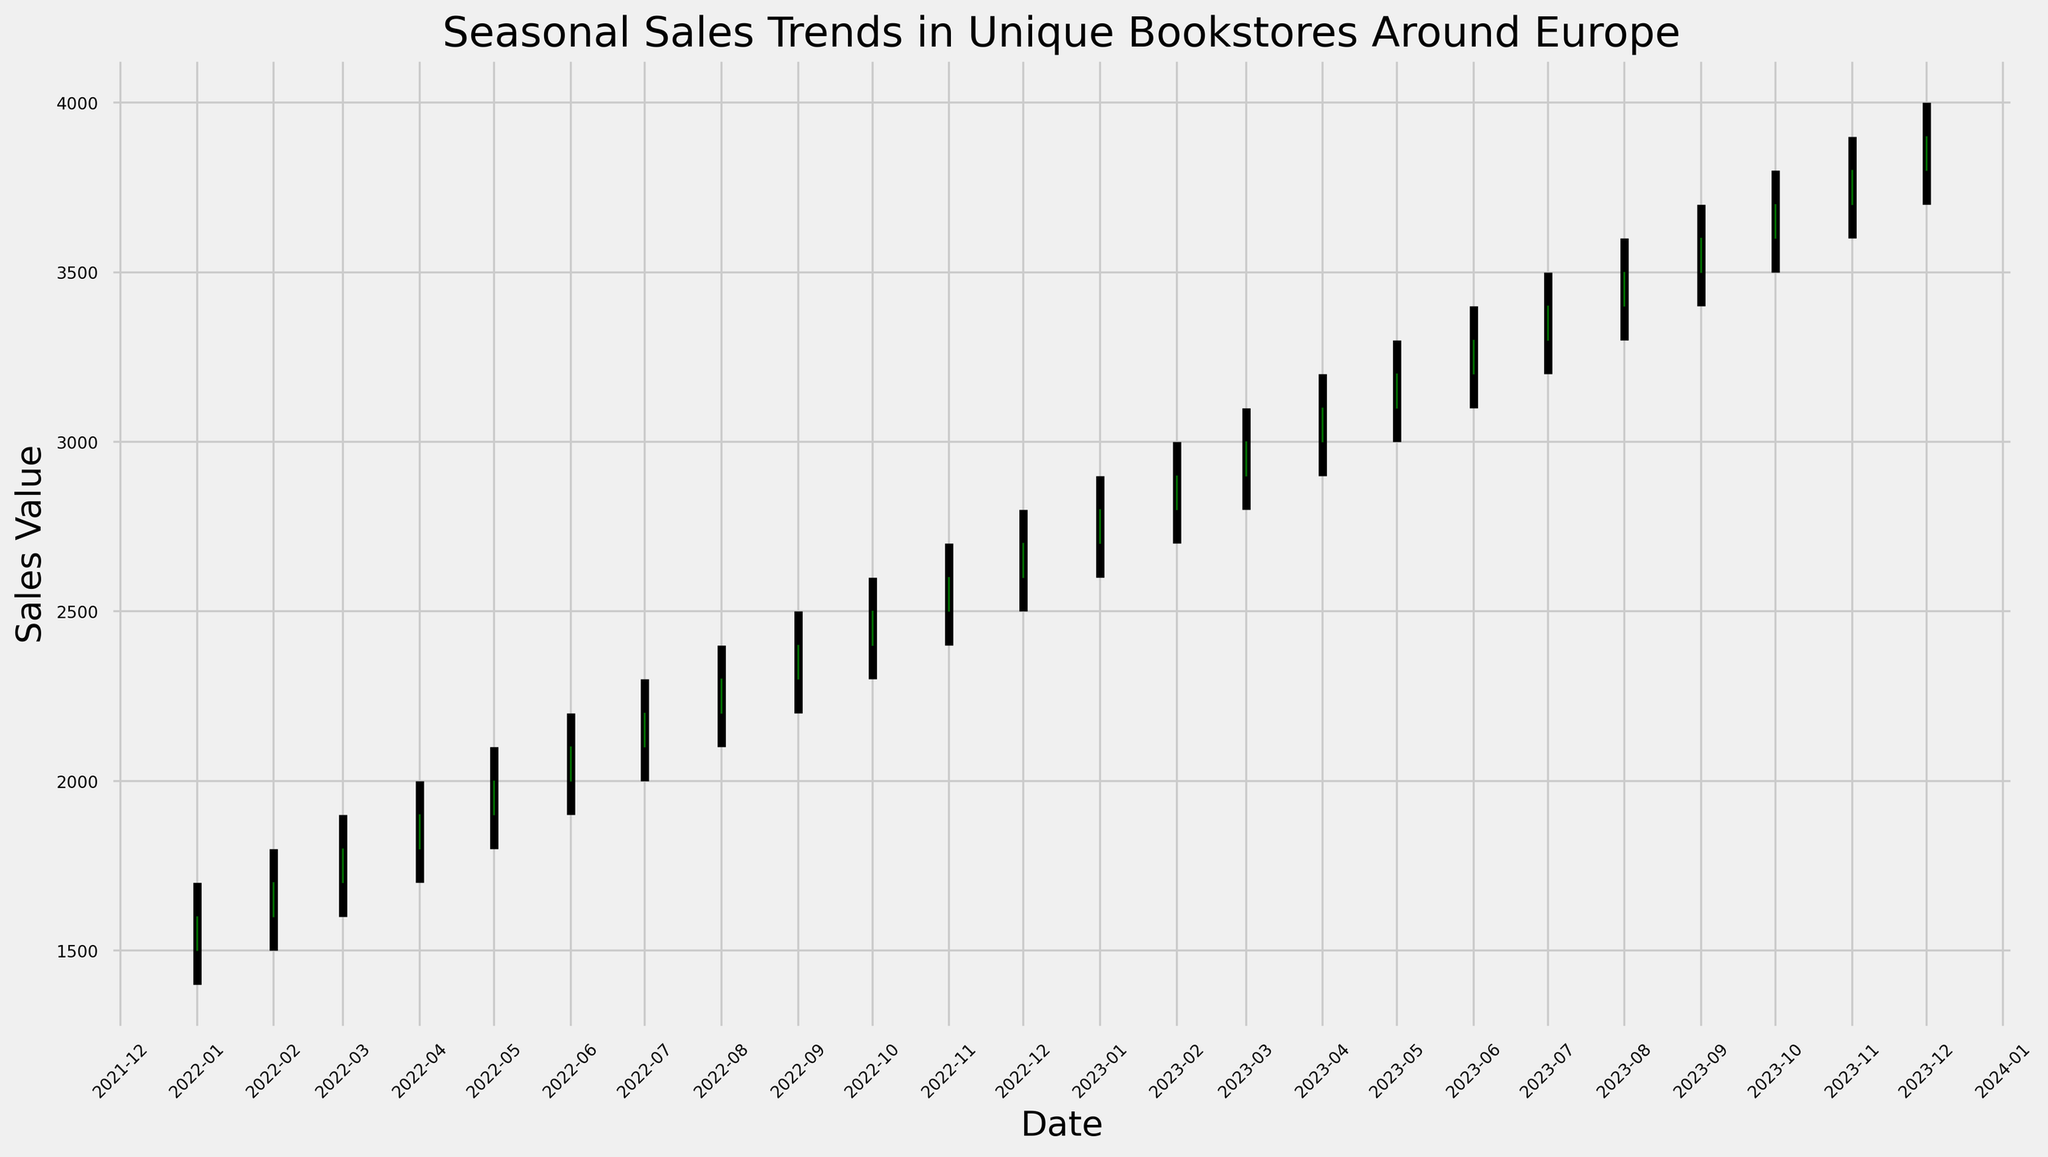What's the overall trend in sales values from January 2022 to December 2023? The plot shows an upward trend as each month on the x-axis corresponds to higher y-axis values moving from January 2022 to December 2023.
Answer: Upward In which month of 2022 did the sales value close higher than it opened? In the candlestick plot, green rectangles represent months when sales closed higher than they opened. For the year 2022, all months from January to December show green rectangles, indicating that the sales closed higher than they opened for every month.
Answer: All months Which month experienced the highest sales peak in 2023? The peak is given by the highest point in the candlestick plot. For 2023, the peak occurs in December, indicated by the highest upper whisker of the candlesticks.
Answer: December How does the sales value in January 2023 compare to January 2022? Look at the candlestick for January 2023 and compare it to January 2022. January 2023's entire range (low to high) is higher than the corresponding range for January 2022.
Answer: Higher What month had the lowest sales minimum in the entire period? The lowest value can be identified by the lowest point on the candlestick chart. This occurs in January 2022.
Answer: January 2022 What is the difference between the highest sale value in December 2022 and December 2023? Identify the high values in both Decembers. The high in December 2022 is 2800 and in December 2023 is 4000. The difference is 4000 - 2800 = 1200.
Answer: 1200 How many months showed a decrease in sales value from the opening to the closing within the entire period? Decreases are represented by red candlesticks. The chart shows no red candlesticks, indicating no months had a decrease in sales value.
Answer: 0 What is the total sales value range (from lowest low to highest high) for the entire period? To find the total range, subtract the lowest low from the highest high. The lowest low is 1400 in January 2022, and the highest high is 4000 in December 2023. Hence, the range is 4000 - 1400 = 2600.
Answer: 2600 Comparing February 2022 and February 2023, in which year was the sales improvement (open to close) greater? For February 2022, the increase was from 1600 to 1700, a difference of 100. For February 2023, the increase was from 2800 to 2900, a difference of 100. Both years show the same improvement (100 units).
Answer: Same 